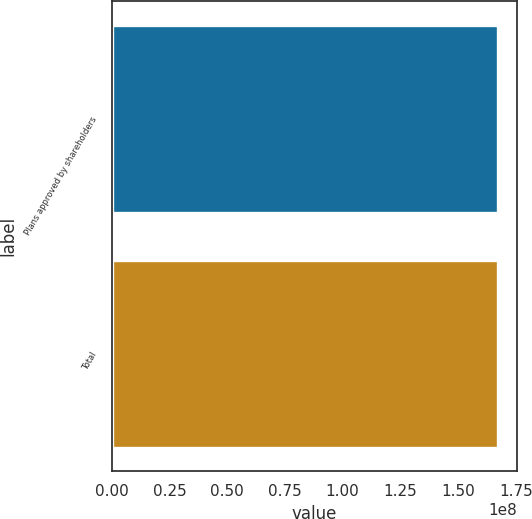Convert chart. <chart><loc_0><loc_0><loc_500><loc_500><bar_chart><fcel>Plans approved by shareholders<fcel>Total<nl><fcel>1.67164e+08<fcel>1.67164e+08<nl></chart> 